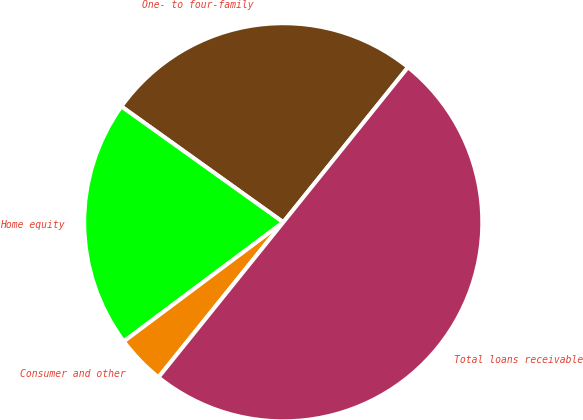Convert chart to OTSL. <chart><loc_0><loc_0><loc_500><loc_500><pie_chart><fcel>One- to four-family<fcel>Home equity<fcel>Consumer and other<fcel>Total loans receivable<nl><fcel>25.9%<fcel>20.1%<fcel>4.0%<fcel>50.0%<nl></chart> 